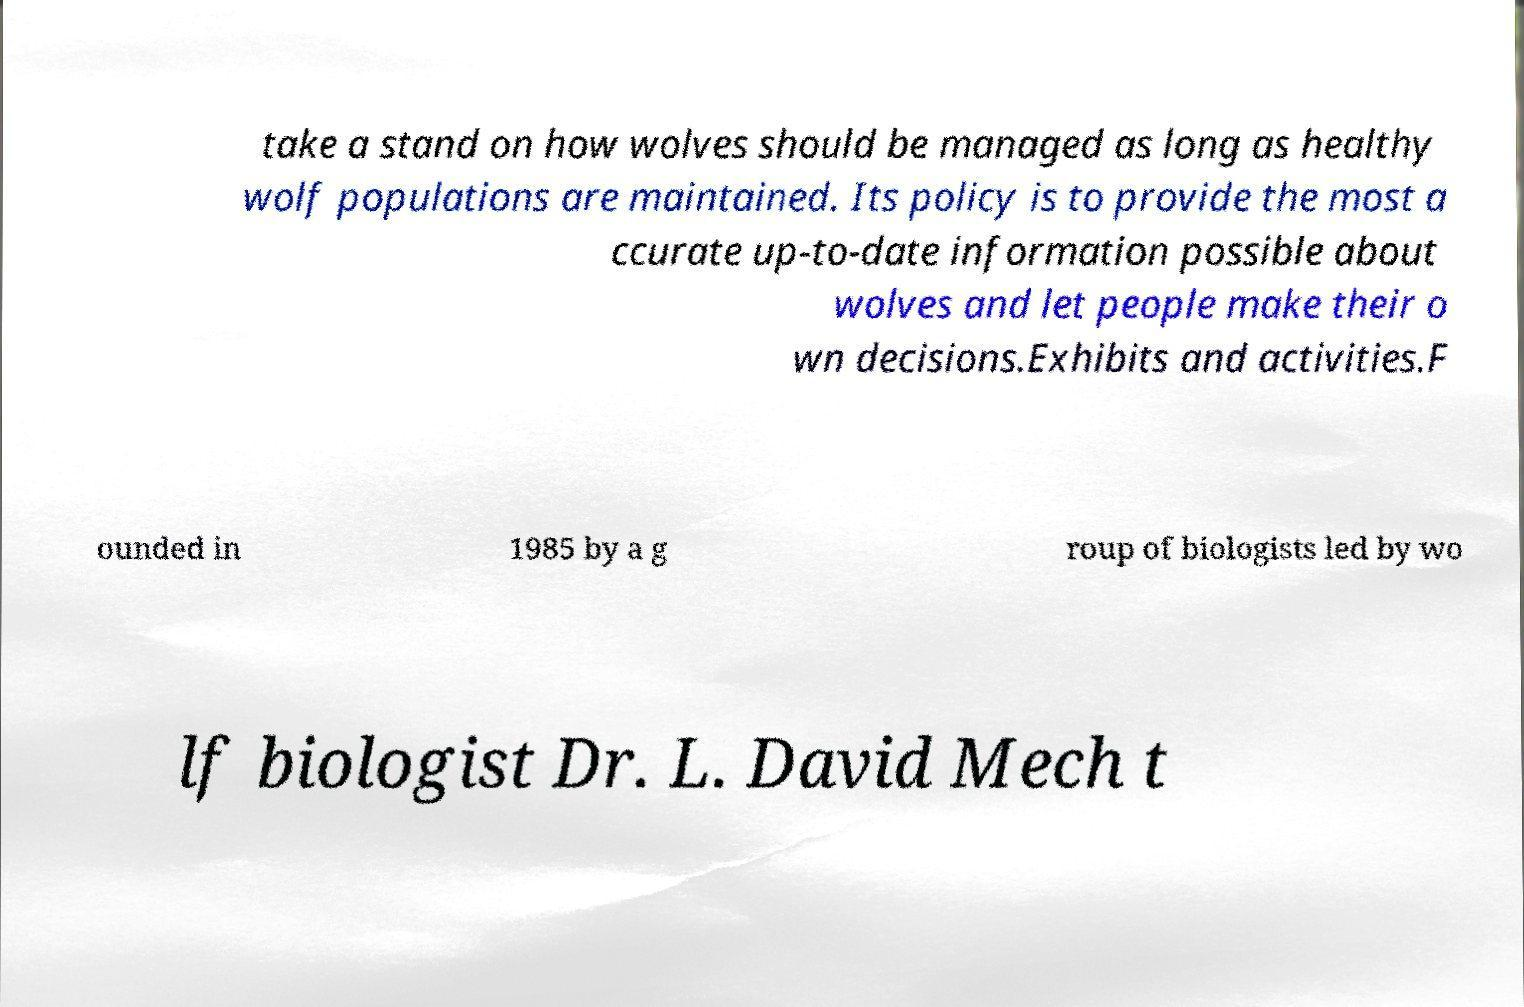For documentation purposes, I need the text within this image transcribed. Could you provide that? take a stand on how wolves should be managed as long as healthy wolf populations are maintained. Its policy is to provide the most a ccurate up-to-date information possible about wolves and let people make their o wn decisions.Exhibits and activities.F ounded in 1985 by a g roup of biologists led by wo lf biologist Dr. L. David Mech t 